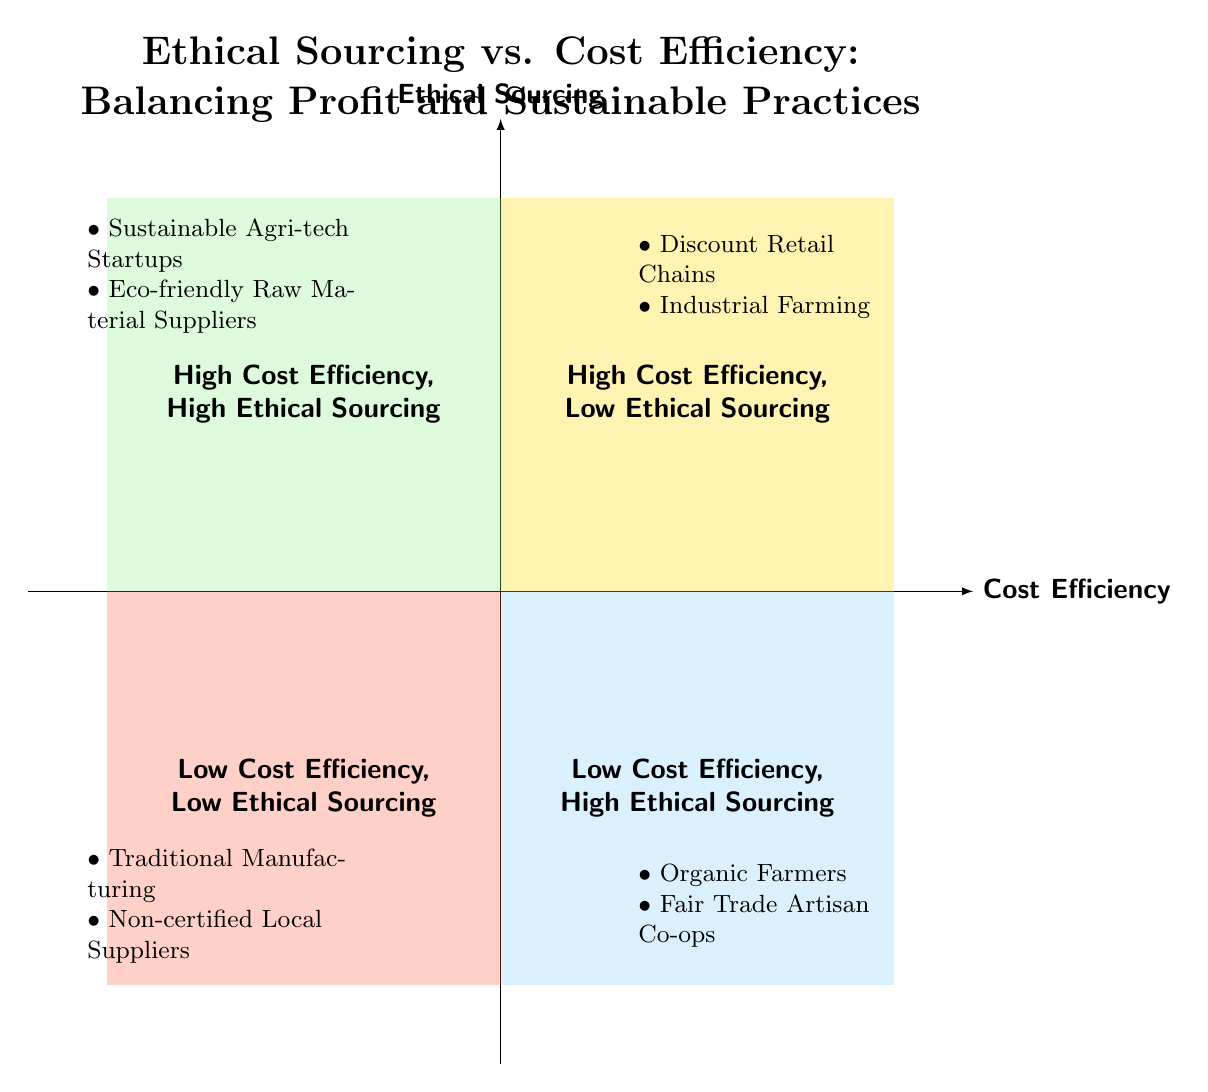What is located in the Top Left quadrant? The Top Left quadrant is labeled "High Cost Efficiency, Low Ethical Sourcing" and contains examples such as "Discount Retail Chains" and "Industrial Farming."
Answer: High Cost Efficiency, Low Ethical Sourcing How many examples are shown in the Bottom Right quadrant? The Bottom Right quadrant is labeled "Low Cost Efficiency, High Ethical Sourcing" and lists two examples: "Organic Farmers" and "Fair Trade Artisan Co-ops." Therefore, there are a total of 2 examples in this quadrant.
Answer: 2 What are the two examples in the Top Right quadrant? The Top Right quadrant is labeled "High Cost Efficiency, High Ethical Sourcing" and includes "Sustainable Agri-tech Startups" and "Eco-friendly Raw Material Suppliers."
Answer: Sustainable Agri-tech Startups, Eco-friendly Raw Material Suppliers Which quadrant has a focus on non-certified local suppliers? The Bottom Left quadrant is labeled "Low Cost Efficiency, Low Ethical Sourcing," and one of its examples is "Non-certified Local Suppliers."
Answer: Bottom Left How does the Low Cost Efficiency, High Ethical Sourcing quadrant compare to the High Cost Efficiency, High Ethical Sourcing quadrant regarding product pricing? The Low Cost Efficiency, High Ethical Sourcing quadrant focuses on higher operational costs, meaning products here tend to be more expensive compared to the High Cost Efficiency, High Ethical Sourcing quadrant, which can offer competitively priced sustainable products.
Answer: More expensive What kind of suppliers do you find in the Bottom Left quadrant? The Bottom Left quadrant consists of suppliers that are characterized by low cost efficiency and low ethical sourcing practices, such as "Traditional Manufacturing" and "Non-certified Local Suppliers."
Answer: Low cost efficiency and low ethical sourcing Which quadrant contains examples that prioritize sustainability while managing costs effectively? The Top Right quadrant is labeled "High Cost Efficiency, High Ethical Sourcing" and includes examples of suppliers and businesses that effectively balance both priorities, such as "Sustainable Agri-tech Startups" and "Eco-friendly Raw Material Suppliers."
Answer: Top Right quadrant What do organic farmers represent in this diagram? Organic Farmers are located in the Bottom Right quadrant labeled "Low Cost Efficiency, High Ethical Sourcing," which signifies that they employ sustainable methods but often incur higher operational costs.
Answer: Low Cost Efficiency, High Ethical Sourcing 